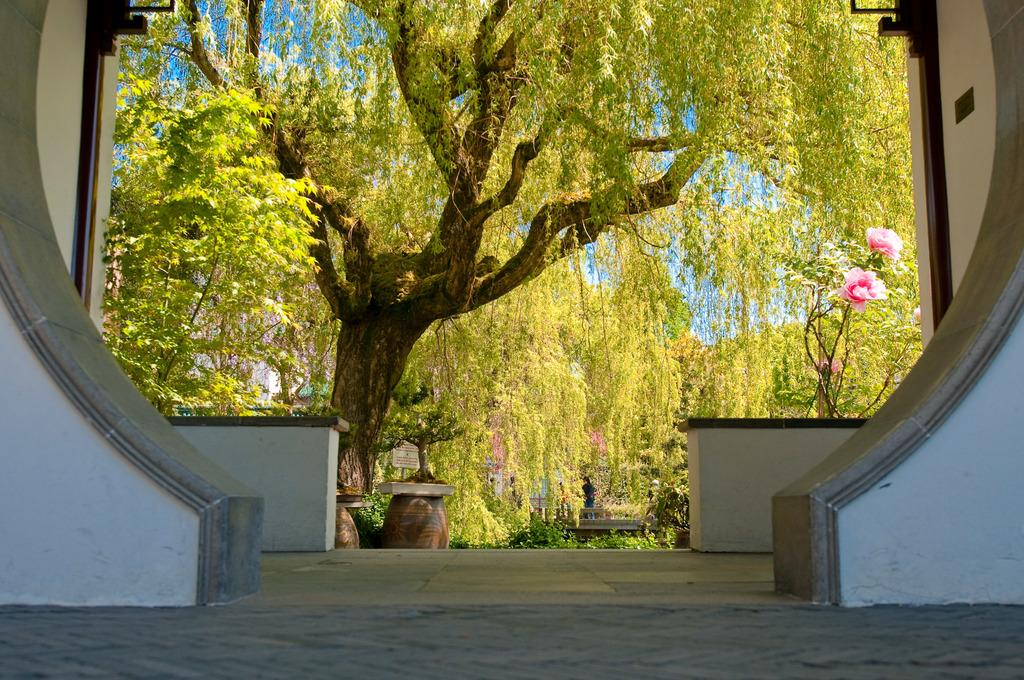What type of natural elements are present in the image? There are many trees and plants in the image. Can you describe the flowers in the image? There are flowers in pink color to the right. What is the surface on which the trees and plants are standing? There is a floor at the bottom of the image. What surrounds the area with trees and plants? There are walls to the left and right. How many slaves can be seen working in the image? There are no slaves present in the image. What type of grape is being harvested in the image? There is no grape or harvesting activity depicted in the image. 